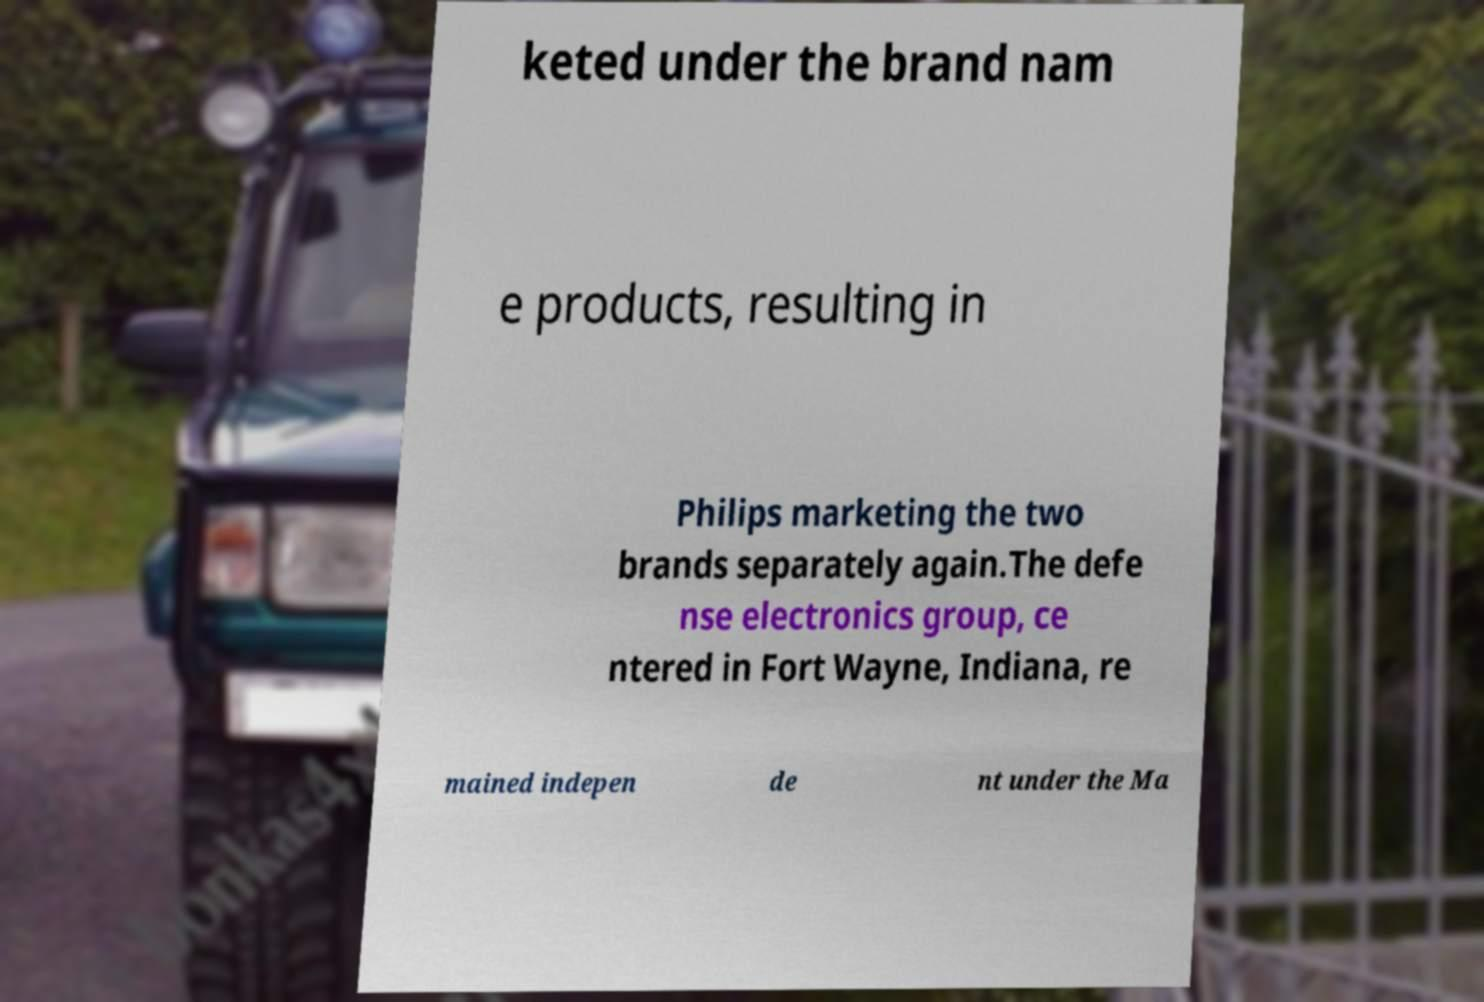Please read and relay the text visible in this image. What does it say? keted under the brand nam e products, resulting in Philips marketing the two brands separately again.The defe nse electronics group, ce ntered in Fort Wayne, Indiana, re mained indepen de nt under the Ma 